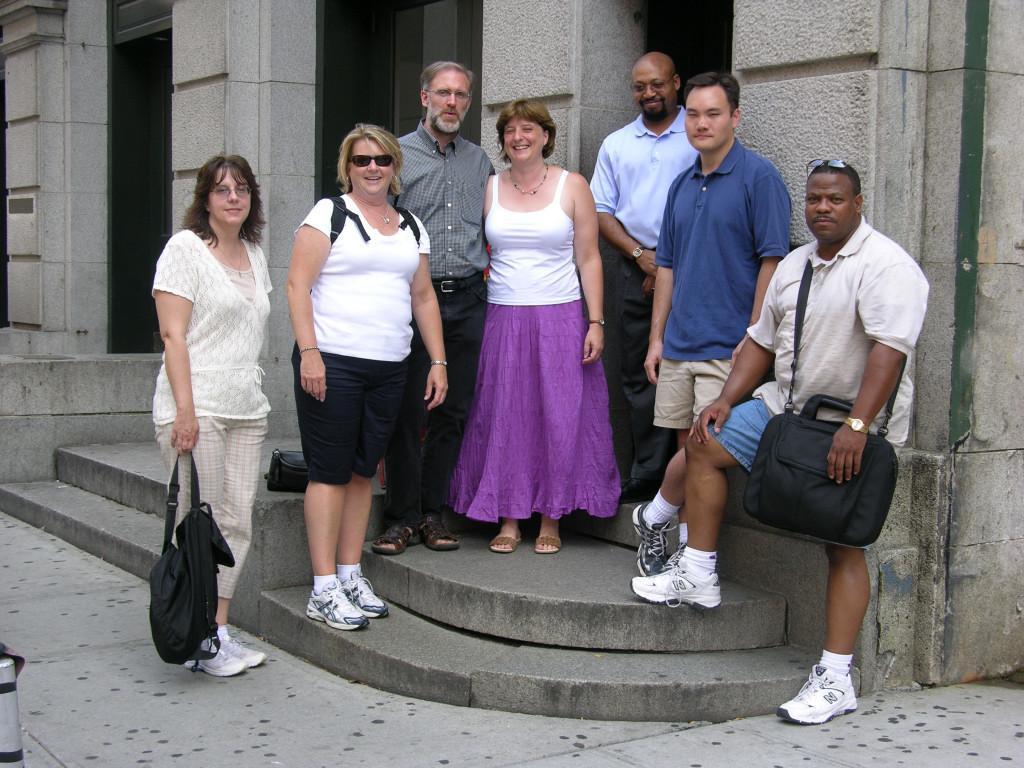How would you summarize this image in a sentence or two? In this image we can see some persons smiling and standing. In the background we can see the building. On the left there is a small pole. 